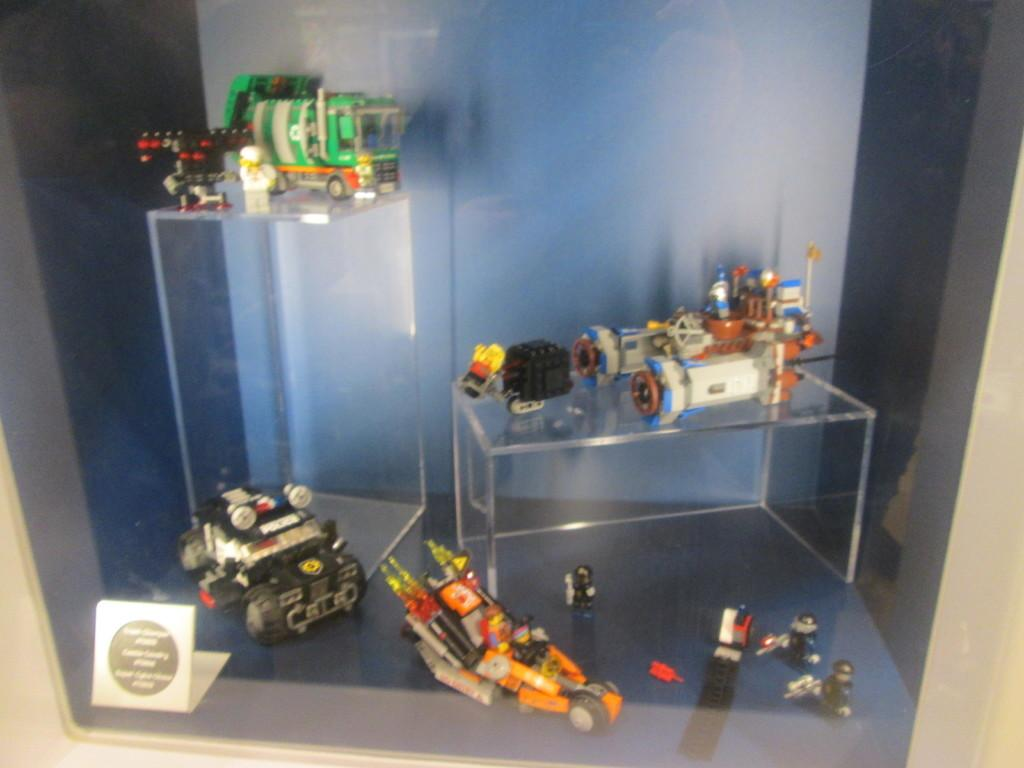What objects are on the glass surface in the image? There are toys on a glass surface in the image. Can you describe the appearance of the toys? The toys are in multiple colors. What is the color scheme of the background wall in the image? The background wall is white and black in color. What type of zipper can be seen on the toys in the image? There are no zippers present on the toys in the image. Can you describe the coastline visible in the image? There is: There is no coastline visible in the image; it features toys on a glass surface with a white and black background wall. 